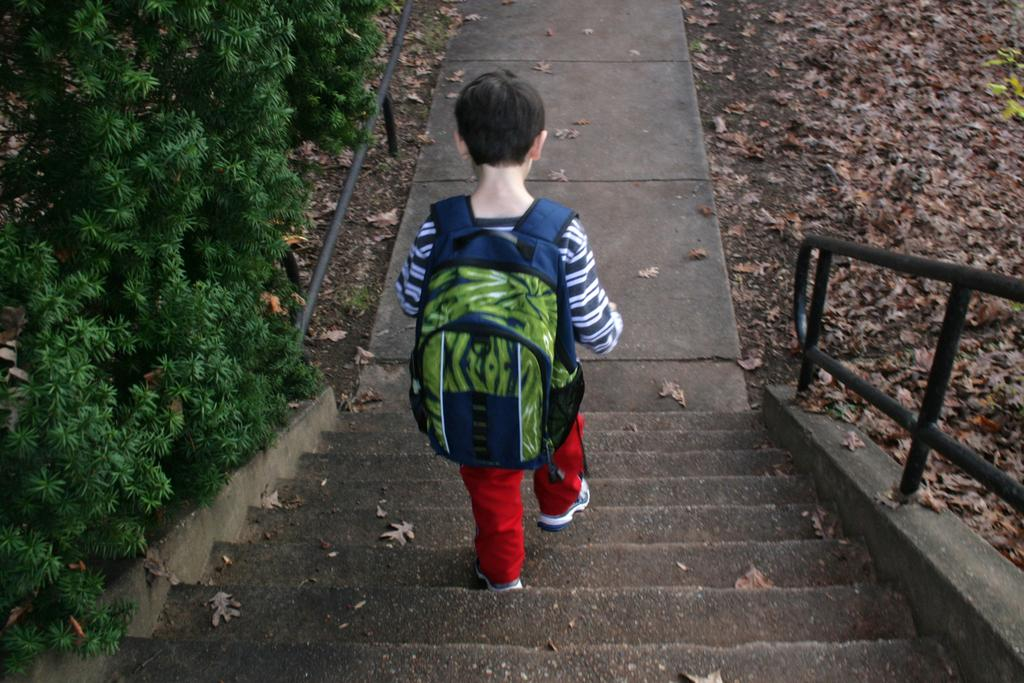Who is the main subject in the image? There is a boy in the image. What is the boy doing in the image? The boy is walking on the sideways of a road. What story is the boy holding in his hand in the image? There is no story visible in the image; the boy is simply walking on the sideways of a road. 